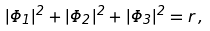Convert formula to latex. <formula><loc_0><loc_0><loc_500><loc_500>| \Phi _ { 1 } | ^ { 2 } + | \Phi _ { 2 } | ^ { 2 } + | \Phi _ { 3 } | ^ { 2 } = r \, ,</formula> 